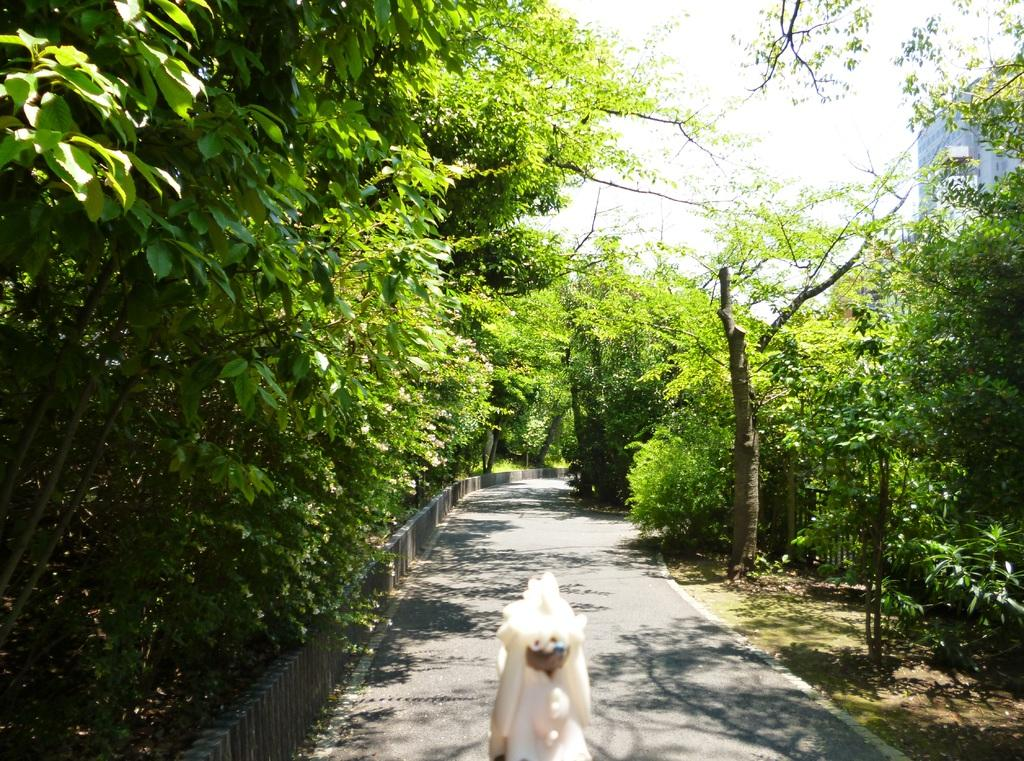What is the main object in the image? There is an object in the image, but its specific nature is not mentioned in the facts. What type of man-made structure can be seen in the image? There is a building in the image. What natural elements are present in the image? There are trees and plants in the image. What is the background of the image? The sky is visible in the image. Is there any indication of a specific location or environment in the image? The presence of a road, trees, and plants suggests a natural or semi-natural setting, but the facts do not specify a location like an island or seashore. Where is the scarecrow standing in the image? There is no scarecrow present in the image. What type of island can be seen in the image? The facts do not mention an island or any specific location, so it is not possible to determine the type of island in the image. 